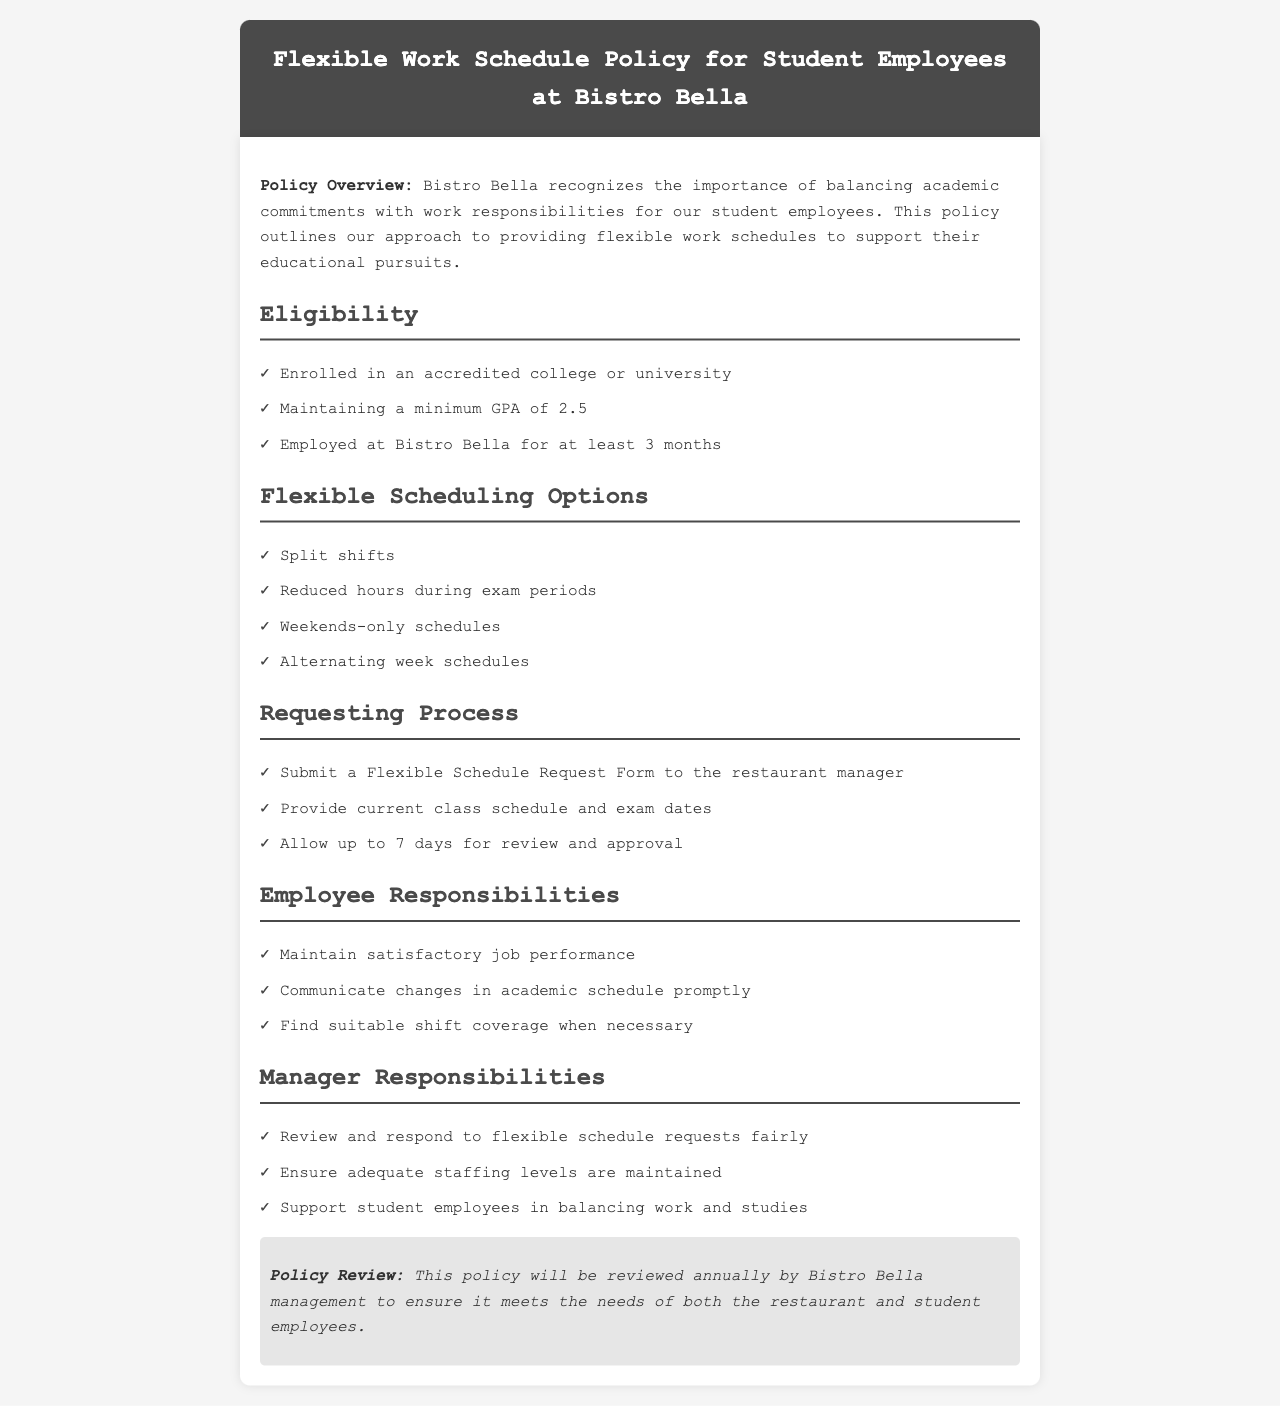What is the minimum GPA required? The minimum GPA required is mentioned under the eligibility section of the document.
Answer: 2.5 How long must a student be employed at Bistro Bella? This information can be found in the eligibility section, which details the employment duration requirement.
Answer: 3 months What should be submitted to request a flexible schedule? The document specifies a form that needs to be submitted for scheduling requests.
Answer: Flexible Schedule Request Form What are the names of the flexible scheduling options available? This information is listed under the flexible scheduling options section.
Answer: Split shifts, Reduced hours during exam periods, Weekends-only schedules, Alternating week schedules How long does it take for the schedule request to be reviewed? The time frame for review is mentioned in the requesting process section.
Answer: 7 days Who is responsible for ensuring adequate staffing levels? This responsibility is detailed under the manager responsibilities section of the document.
Answer: Manager What is the purpose of the policy review? The policy review’s purpose is to ensure it meets the needs of specific groups involved.
Answer: Maintain needs of restaurant and student employees What must an employee do if there are changes in their academic schedule? This responsibility for communication is mentioned under employee responsibilities.
Answer: Communicate changes promptly 